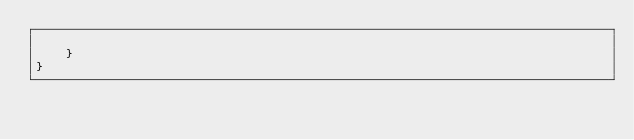Convert code to text. <code><loc_0><loc_0><loc_500><loc_500><_Kotlin_>
    }
}</code> 